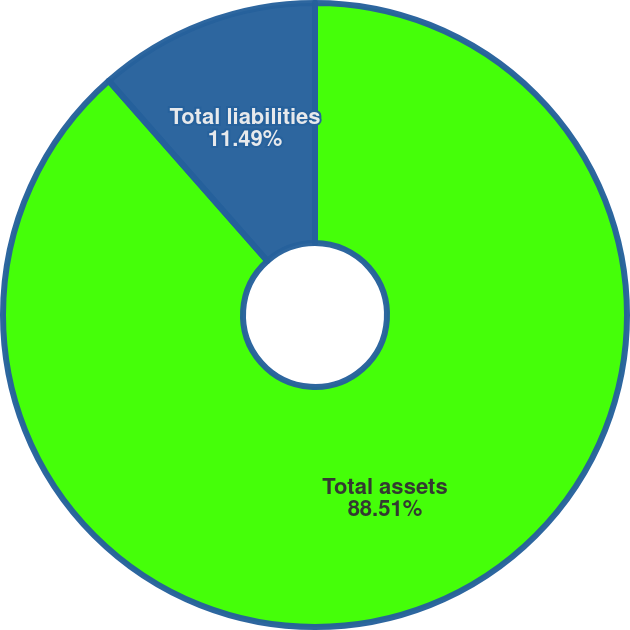Convert chart to OTSL. <chart><loc_0><loc_0><loc_500><loc_500><pie_chart><fcel>Total assets<fcel>Total liabilities<nl><fcel>88.51%<fcel>11.49%<nl></chart> 